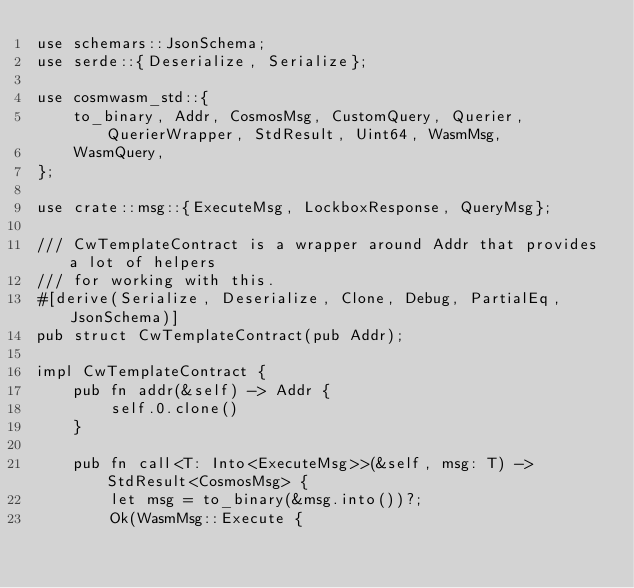Convert code to text. <code><loc_0><loc_0><loc_500><loc_500><_Rust_>use schemars::JsonSchema;
use serde::{Deserialize, Serialize};

use cosmwasm_std::{
    to_binary, Addr, CosmosMsg, CustomQuery, Querier, QuerierWrapper, StdResult, Uint64, WasmMsg,
    WasmQuery,
};

use crate::msg::{ExecuteMsg, LockboxResponse, QueryMsg};

/// CwTemplateContract is a wrapper around Addr that provides a lot of helpers
/// for working with this.
#[derive(Serialize, Deserialize, Clone, Debug, PartialEq, JsonSchema)]
pub struct CwTemplateContract(pub Addr);

impl CwTemplateContract {
    pub fn addr(&self) -> Addr {
        self.0.clone()
    }

    pub fn call<T: Into<ExecuteMsg>>(&self, msg: T) -> StdResult<CosmosMsg> {
        let msg = to_binary(&msg.into())?;
        Ok(WasmMsg::Execute {</code> 